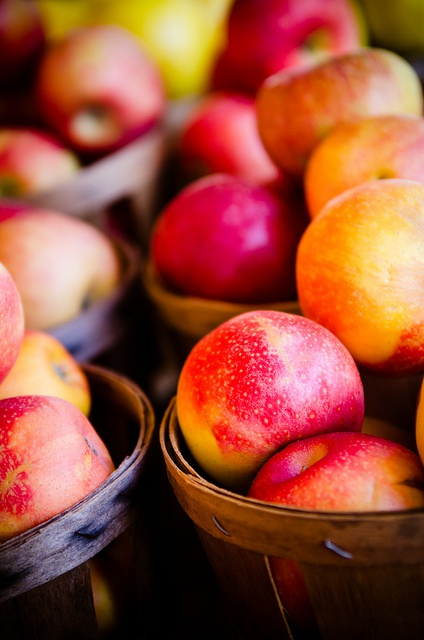Describe the objects in this image and their specific colors. I can see apple in maroon, red, salmon, and lightpink tones, apple in maroon, red, orange, tan, and gold tones, apple in maroon, lightpink, salmon, and tan tones, apple in maroon and brown tones, and bowl in maroon, black, and brown tones in this image. 